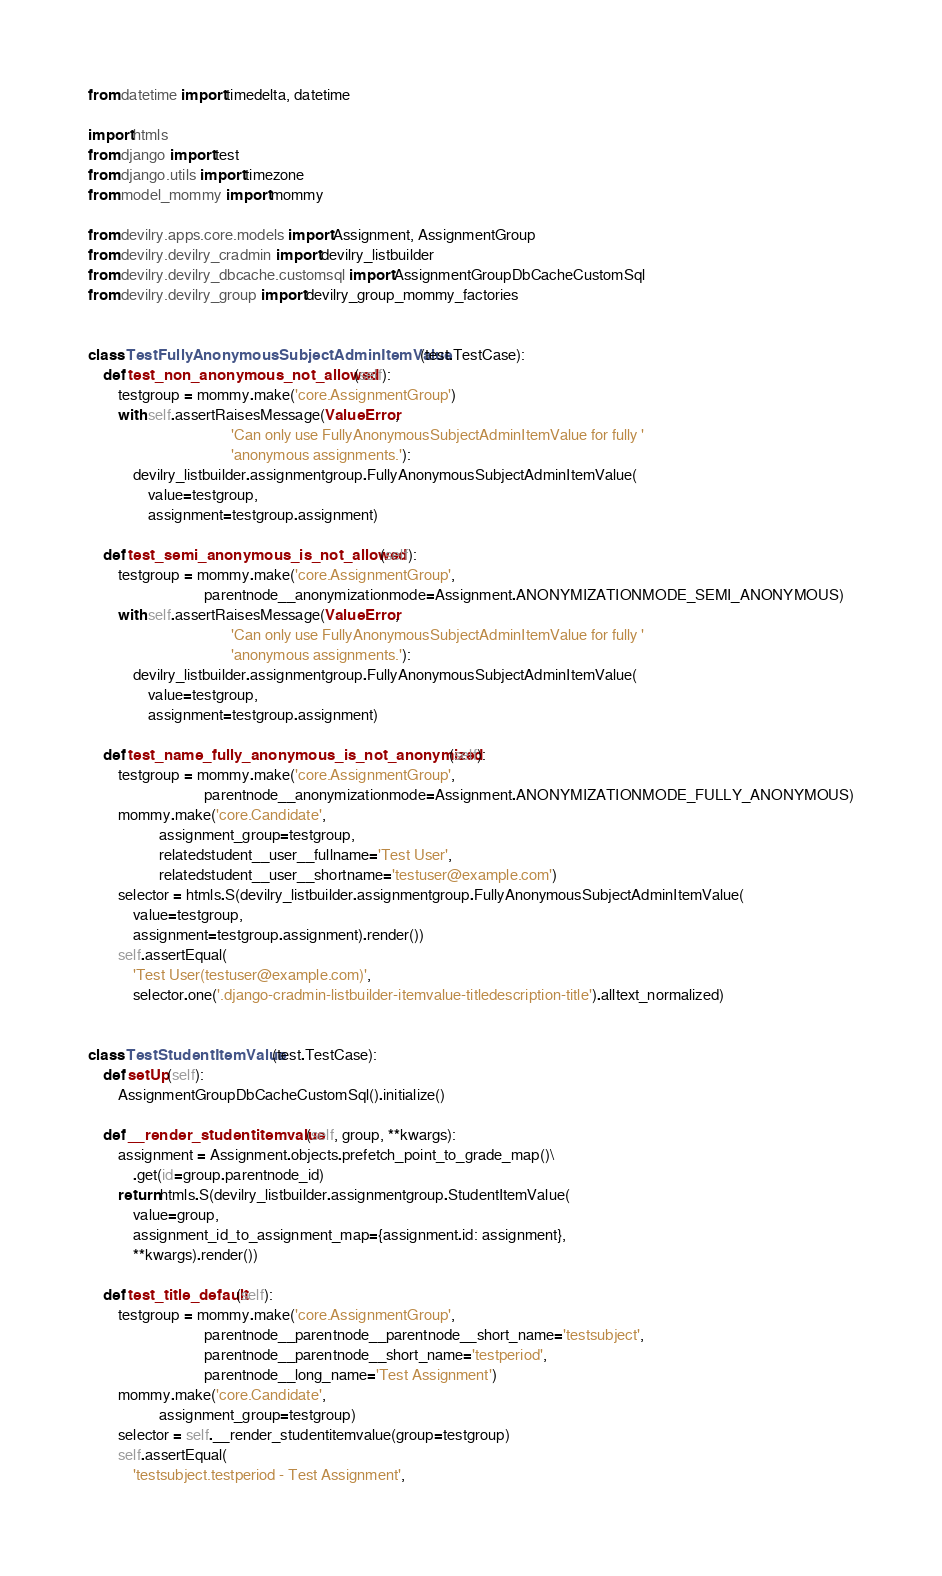Convert code to text. <code><loc_0><loc_0><loc_500><loc_500><_Python_>from datetime import timedelta, datetime

import htmls
from django import test
from django.utils import timezone
from model_mommy import mommy

from devilry.apps.core.models import Assignment, AssignmentGroup
from devilry.devilry_cradmin import devilry_listbuilder
from devilry.devilry_dbcache.customsql import AssignmentGroupDbCacheCustomSql
from devilry.devilry_group import devilry_group_mommy_factories


class TestFullyAnonymousSubjectAdminItemValue(test.TestCase):
    def test_non_anonymous_not_allowed(self):
        testgroup = mommy.make('core.AssignmentGroup')
        with self.assertRaisesMessage(ValueError,
                                      'Can only use FullyAnonymousSubjectAdminItemValue for fully '
                                      'anonymous assignments.'):
            devilry_listbuilder.assignmentgroup.FullyAnonymousSubjectAdminItemValue(
                value=testgroup,
                assignment=testgroup.assignment)

    def test_semi_anonymous_is_not_allowed(self):
        testgroup = mommy.make('core.AssignmentGroup',
                               parentnode__anonymizationmode=Assignment.ANONYMIZATIONMODE_SEMI_ANONYMOUS)
        with self.assertRaisesMessage(ValueError,
                                      'Can only use FullyAnonymousSubjectAdminItemValue for fully '
                                      'anonymous assignments.'):
            devilry_listbuilder.assignmentgroup.FullyAnonymousSubjectAdminItemValue(
                value=testgroup,
                assignment=testgroup.assignment)

    def test_name_fully_anonymous_is_not_anonymized(self):
        testgroup = mommy.make('core.AssignmentGroup',
                               parentnode__anonymizationmode=Assignment.ANONYMIZATIONMODE_FULLY_ANONYMOUS)
        mommy.make('core.Candidate',
                   assignment_group=testgroup,
                   relatedstudent__user__fullname='Test User',
                   relatedstudent__user__shortname='testuser@example.com')
        selector = htmls.S(devilry_listbuilder.assignmentgroup.FullyAnonymousSubjectAdminItemValue(
            value=testgroup,
            assignment=testgroup.assignment).render())
        self.assertEqual(
            'Test User(testuser@example.com)',
            selector.one('.django-cradmin-listbuilder-itemvalue-titledescription-title').alltext_normalized)


class TestStudentItemValue(test.TestCase):
    def setUp(self):
        AssignmentGroupDbCacheCustomSql().initialize()

    def __render_studentitemvalue(self, group, **kwargs):
        assignment = Assignment.objects.prefetch_point_to_grade_map()\
            .get(id=group.parentnode_id)
        return htmls.S(devilry_listbuilder.assignmentgroup.StudentItemValue(
            value=group,
            assignment_id_to_assignment_map={assignment.id: assignment},
            **kwargs).render())

    def test_title_default(self):
        testgroup = mommy.make('core.AssignmentGroup',
                               parentnode__parentnode__parentnode__short_name='testsubject',
                               parentnode__parentnode__short_name='testperiod',
                               parentnode__long_name='Test Assignment')
        mommy.make('core.Candidate',
                   assignment_group=testgroup)
        selector = self.__render_studentitemvalue(group=testgroup)
        self.assertEqual(
            'testsubject.testperiod - Test Assignment',</code> 